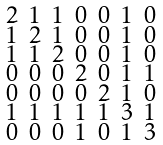Convert formula to latex. <formula><loc_0><loc_0><loc_500><loc_500>\begin{smallmatrix} 2 & 1 & 1 & 0 & 0 & 1 & 0 \\ 1 & 2 & 1 & 0 & 0 & 1 & 0 \\ 1 & 1 & 2 & 0 & 0 & 1 & 0 \\ 0 & 0 & 0 & 2 & 0 & 1 & 1 \\ 0 & 0 & 0 & 0 & 2 & 1 & 0 \\ 1 & 1 & 1 & 1 & 1 & 3 & 1 \\ 0 & 0 & 0 & 1 & 0 & 1 & 3 \end{smallmatrix}</formula> 